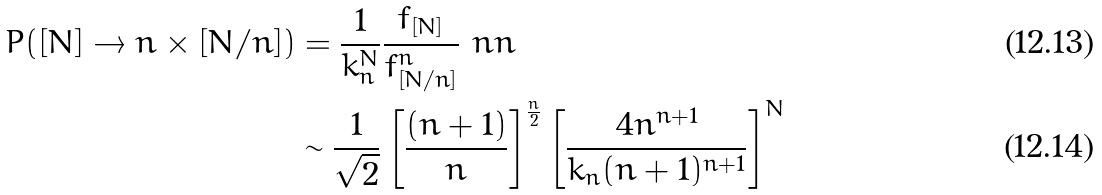<formula> <loc_0><loc_0><loc_500><loc_500>P ( [ N ] \to n \times [ N / n ] ) & = \frac { 1 } { k _ { n } ^ { N } } \frac { f _ { [ N ] } } { f _ { [ N / n ] } ^ { n } } \ n n \\ & \sim \frac { 1 } { \sqrt { 2 } } \left [ \frac { ( n + 1 ) } { n } \right ] ^ { \frac { n } { 2 } } \left [ \frac { 4 n ^ { n + 1 } } { k _ { n } ( n + 1 ) ^ { n + 1 } } \right ] ^ { N }</formula> 